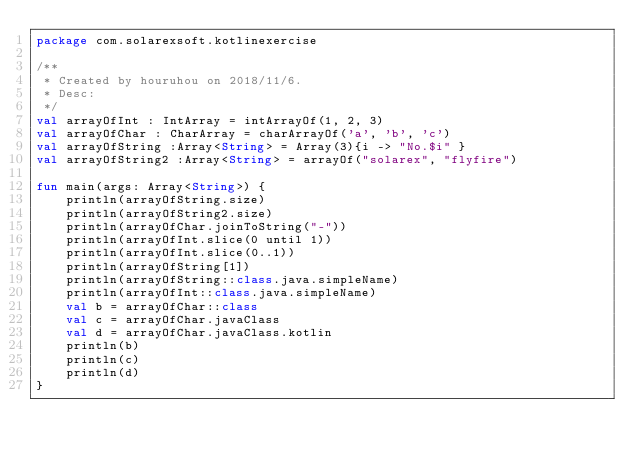<code> <loc_0><loc_0><loc_500><loc_500><_Kotlin_>package com.solarexsoft.kotlinexercise

/**
 * Created by houruhou on 2018/11/6.
 * Desc:
 */
val arrayOfInt : IntArray = intArrayOf(1, 2, 3)
val arrayOfChar : CharArray = charArrayOf('a', 'b', 'c')
val arrayOfString :Array<String> = Array(3){i -> "No.$i" }
val arrayOfString2 :Array<String> = arrayOf("solarex", "flyfire")

fun main(args: Array<String>) {
    println(arrayOfString.size)
    println(arrayOfString2.size)
    println(arrayOfChar.joinToString("-"))
    println(arrayOfInt.slice(0 until 1))
    println(arrayOfInt.slice(0..1))
    println(arrayOfString[1])
    println(arrayOfString::class.java.simpleName)
    println(arrayOfInt::class.java.simpleName)
    val b = arrayOfChar::class
    val c = arrayOfChar.javaClass
    val d = arrayOfChar.javaClass.kotlin
    println(b)
    println(c)
    println(d)
}</code> 